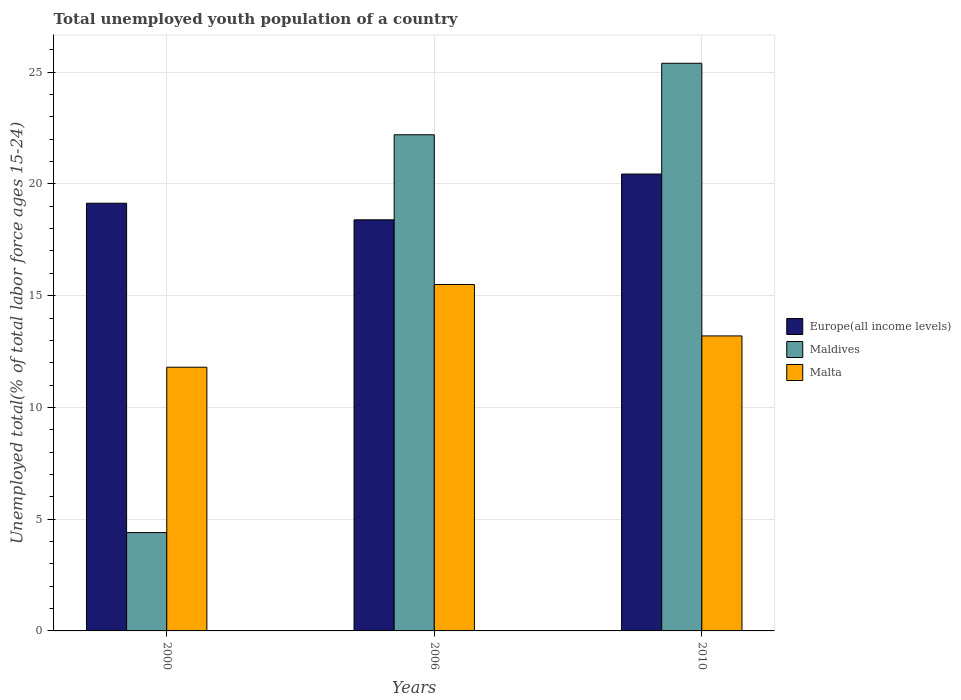How many different coloured bars are there?
Your answer should be very brief. 3. Are the number of bars on each tick of the X-axis equal?
Offer a very short reply. Yes. How many bars are there on the 2nd tick from the left?
Your answer should be compact. 3. What is the label of the 2nd group of bars from the left?
Your answer should be very brief. 2006. In how many cases, is the number of bars for a given year not equal to the number of legend labels?
Your answer should be very brief. 0. What is the percentage of total unemployed youth population of a country in Europe(all income levels) in 2010?
Give a very brief answer. 20.44. Across all years, what is the maximum percentage of total unemployed youth population of a country in Europe(all income levels)?
Provide a short and direct response. 20.44. Across all years, what is the minimum percentage of total unemployed youth population of a country in Europe(all income levels)?
Offer a terse response. 18.4. In which year was the percentage of total unemployed youth population of a country in Europe(all income levels) maximum?
Make the answer very short. 2010. In which year was the percentage of total unemployed youth population of a country in Malta minimum?
Your response must be concise. 2000. What is the total percentage of total unemployed youth population of a country in Europe(all income levels) in the graph?
Make the answer very short. 57.98. What is the difference between the percentage of total unemployed youth population of a country in Malta in 2000 and that in 2006?
Provide a succinct answer. -3.7. What is the difference between the percentage of total unemployed youth population of a country in Maldives in 2000 and the percentage of total unemployed youth population of a country in Malta in 2010?
Provide a succinct answer. -8.8. In the year 2000, what is the difference between the percentage of total unemployed youth population of a country in Malta and percentage of total unemployed youth population of a country in Maldives?
Provide a short and direct response. 7.4. In how many years, is the percentage of total unemployed youth population of a country in Maldives greater than 14 %?
Provide a short and direct response. 2. What is the ratio of the percentage of total unemployed youth population of a country in Europe(all income levels) in 2000 to that in 2006?
Ensure brevity in your answer.  1.04. Is the percentage of total unemployed youth population of a country in Maldives in 2000 less than that in 2010?
Give a very brief answer. Yes. Is the difference between the percentage of total unemployed youth population of a country in Malta in 2006 and 2010 greater than the difference between the percentage of total unemployed youth population of a country in Maldives in 2006 and 2010?
Offer a terse response. Yes. What is the difference between the highest and the second highest percentage of total unemployed youth population of a country in Malta?
Keep it short and to the point. 2.3. What is the difference between the highest and the lowest percentage of total unemployed youth population of a country in Maldives?
Ensure brevity in your answer.  21. In how many years, is the percentage of total unemployed youth population of a country in Maldives greater than the average percentage of total unemployed youth population of a country in Maldives taken over all years?
Ensure brevity in your answer.  2. What does the 2nd bar from the left in 2000 represents?
Your response must be concise. Maldives. What does the 2nd bar from the right in 2010 represents?
Your answer should be compact. Maldives. How many years are there in the graph?
Provide a succinct answer. 3. Are the values on the major ticks of Y-axis written in scientific E-notation?
Offer a terse response. No. Does the graph contain any zero values?
Make the answer very short. No. How many legend labels are there?
Make the answer very short. 3. How are the legend labels stacked?
Your answer should be compact. Vertical. What is the title of the graph?
Your answer should be compact. Total unemployed youth population of a country. What is the label or title of the Y-axis?
Your answer should be compact. Unemployed total(% of total labor force ages 15-24). What is the Unemployed total(% of total labor force ages 15-24) in Europe(all income levels) in 2000?
Provide a succinct answer. 19.14. What is the Unemployed total(% of total labor force ages 15-24) in Maldives in 2000?
Your answer should be very brief. 4.4. What is the Unemployed total(% of total labor force ages 15-24) of Malta in 2000?
Offer a very short reply. 11.8. What is the Unemployed total(% of total labor force ages 15-24) of Europe(all income levels) in 2006?
Provide a short and direct response. 18.4. What is the Unemployed total(% of total labor force ages 15-24) in Maldives in 2006?
Provide a short and direct response. 22.2. What is the Unemployed total(% of total labor force ages 15-24) in Europe(all income levels) in 2010?
Make the answer very short. 20.44. What is the Unemployed total(% of total labor force ages 15-24) in Maldives in 2010?
Offer a very short reply. 25.4. What is the Unemployed total(% of total labor force ages 15-24) of Malta in 2010?
Your answer should be very brief. 13.2. Across all years, what is the maximum Unemployed total(% of total labor force ages 15-24) of Europe(all income levels)?
Provide a short and direct response. 20.44. Across all years, what is the maximum Unemployed total(% of total labor force ages 15-24) in Maldives?
Your answer should be compact. 25.4. Across all years, what is the minimum Unemployed total(% of total labor force ages 15-24) of Europe(all income levels)?
Your answer should be compact. 18.4. Across all years, what is the minimum Unemployed total(% of total labor force ages 15-24) of Maldives?
Provide a short and direct response. 4.4. Across all years, what is the minimum Unemployed total(% of total labor force ages 15-24) of Malta?
Your answer should be compact. 11.8. What is the total Unemployed total(% of total labor force ages 15-24) of Europe(all income levels) in the graph?
Your response must be concise. 57.98. What is the total Unemployed total(% of total labor force ages 15-24) in Malta in the graph?
Give a very brief answer. 40.5. What is the difference between the Unemployed total(% of total labor force ages 15-24) of Europe(all income levels) in 2000 and that in 2006?
Keep it short and to the point. 0.74. What is the difference between the Unemployed total(% of total labor force ages 15-24) of Maldives in 2000 and that in 2006?
Ensure brevity in your answer.  -17.8. What is the difference between the Unemployed total(% of total labor force ages 15-24) of Malta in 2000 and that in 2006?
Give a very brief answer. -3.7. What is the difference between the Unemployed total(% of total labor force ages 15-24) in Europe(all income levels) in 2000 and that in 2010?
Your answer should be compact. -1.31. What is the difference between the Unemployed total(% of total labor force ages 15-24) in Maldives in 2000 and that in 2010?
Provide a succinct answer. -21. What is the difference between the Unemployed total(% of total labor force ages 15-24) in Europe(all income levels) in 2006 and that in 2010?
Offer a very short reply. -2.05. What is the difference between the Unemployed total(% of total labor force ages 15-24) in Maldives in 2006 and that in 2010?
Keep it short and to the point. -3.2. What is the difference between the Unemployed total(% of total labor force ages 15-24) in Europe(all income levels) in 2000 and the Unemployed total(% of total labor force ages 15-24) in Maldives in 2006?
Keep it short and to the point. -3.06. What is the difference between the Unemployed total(% of total labor force ages 15-24) in Europe(all income levels) in 2000 and the Unemployed total(% of total labor force ages 15-24) in Malta in 2006?
Your answer should be compact. 3.64. What is the difference between the Unemployed total(% of total labor force ages 15-24) of Maldives in 2000 and the Unemployed total(% of total labor force ages 15-24) of Malta in 2006?
Provide a short and direct response. -11.1. What is the difference between the Unemployed total(% of total labor force ages 15-24) in Europe(all income levels) in 2000 and the Unemployed total(% of total labor force ages 15-24) in Maldives in 2010?
Make the answer very short. -6.26. What is the difference between the Unemployed total(% of total labor force ages 15-24) in Europe(all income levels) in 2000 and the Unemployed total(% of total labor force ages 15-24) in Malta in 2010?
Provide a short and direct response. 5.94. What is the difference between the Unemployed total(% of total labor force ages 15-24) in Maldives in 2000 and the Unemployed total(% of total labor force ages 15-24) in Malta in 2010?
Offer a terse response. -8.8. What is the difference between the Unemployed total(% of total labor force ages 15-24) in Europe(all income levels) in 2006 and the Unemployed total(% of total labor force ages 15-24) in Maldives in 2010?
Provide a short and direct response. -7. What is the difference between the Unemployed total(% of total labor force ages 15-24) in Europe(all income levels) in 2006 and the Unemployed total(% of total labor force ages 15-24) in Malta in 2010?
Offer a terse response. 5.2. What is the average Unemployed total(% of total labor force ages 15-24) of Europe(all income levels) per year?
Provide a short and direct response. 19.33. What is the average Unemployed total(% of total labor force ages 15-24) of Maldives per year?
Offer a terse response. 17.33. What is the average Unemployed total(% of total labor force ages 15-24) in Malta per year?
Offer a very short reply. 13.5. In the year 2000, what is the difference between the Unemployed total(% of total labor force ages 15-24) in Europe(all income levels) and Unemployed total(% of total labor force ages 15-24) in Maldives?
Give a very brief answer. 14.74. In the year 2000, what is the difference between the Unemployed total(% of total labor force ages 15-24) in Europe(all income levels) and Unemployed total(% of total labor force ages 15-24) in Malta?
Provide a succinct answer. 7.34. In the year 2000, what is the difference between the Unemployed total(% of total labor force ages 15-24) in Maldives and Unemployed total(% of total labor force ages 15-24) in Malta?
Offer a terse response. -7.4. In the year 2006, what is the difference between the Unemployed total(% of total labor force ages 15-24) in Europe(all income levels) and Unemployed total(% of total labor force ages 15-24) in Maldives?
Your response must be concise. -3.8. In the year 2006, what is the difference between the Unemployed total(% of total labor force ages 15-24) of Europe(all income levels) and Unemployed total(% of total labor force ages 15-24) of Malta?
Ensure brevity in your answer.  2.9. In the year 2006, what is the difference between the Unemployed total(% of total labor force ages 15-24) of Maldives and Unemployed total(% of total labor force ages 15-24) of Malta?
Provide a succinct answer. 6.7. In the year 2010, what is the difference between the Unemployed total(% of total labor force ages 15-24) in Europe(all income levels) and Unemployed total(% of total labor force ages 15-24) in Maldives?
Provide a succinct answer. -4.96. In the year 2010, what is the difference between the Unemployed total(% of total labor force ages 15-24) of Europe(all income levels) and Unemployed total(% of total labor force ages 15-24) of Malta?
Keep it short and to the point. 7.24. In the year 2010, what is the difference between the Unemployed total(% of total labor force ages 15-24) of Maldives and Unemployed total(% of total labor force ages 15-24) of Malta?
Your answer should be very brief. 12.2. What is the ratio of the Unemployed total(% of total labor force ages 15-24) of Europe(all income levels) in 2000 to that in 2006?
Make the answer very short. 1.04. What is the ratio of the Unemployed total(% of total labor force ages 15-24) of Maldives in 2000 to that in 2006?
Provide a succinct answer. 0.2. What is the ratio of the Unemployed total(% of total labor force ages 15-24) in Malta in 2000 to that in 2006?
Offer a terse response. 0.76. What is the ratio of the Unemployed total(% of total labor force ages 15-24) in Europe(all income levels) in 2000 to that in 2010?
Your answer should be compact. 0.94. What is the ratio of the Unemployed total(% of total labor force ages 15-24) of Maldives in 2000 to that in 2010?
Your response must be concise. 0.17. What is the ratio of the Unemployed total(% of total labor force ages 15-24) in Malta in 2000 to that in 2010?
Keep it short and to the point. 0.89. What is the ratio of the Unemployed total(% of total labor force ages 15-24) in Europe(all income levels) in 2006 to that in 2010?
Give a very brief answer. 0.9. What is the ratio of the Unemployed total(% of total labor force ages 15-24) in Maldives in 2006 to that in 2010?
Offer a very short reply. 0.87. What is the ratio of the Unemployed total(% of total labor force ages 15-24) in Malta in 2006 to that in 2010?
Your answer should be compact. 1.17. What is the difference between the highest and the second highest Unemployed total(% of total labor force ages 15-24) in Europe(all income levels)?
Ensure brevity in your answer.  1.31. What is the difference between the highest and the second highest Unemployed total(% of total labor force ages 15-24) in Malta?
Your answer should be very brief. 2.3. What is the difference between the highest and the lowest Unemployed total(% of total labor force ages 15-24) in Europe(all income levels)?
Your response must be concise. 2.05. What is the difference between the highest and the lowest Unemployed total(% of total labor force ages 15-24) in Maldives?
Give a very brief answer. 21. What is the difference between the highest and the lowest Unemployed total(% of total labor force ages 15-24) of Malta?
Offer a very short reply. 3.7. 